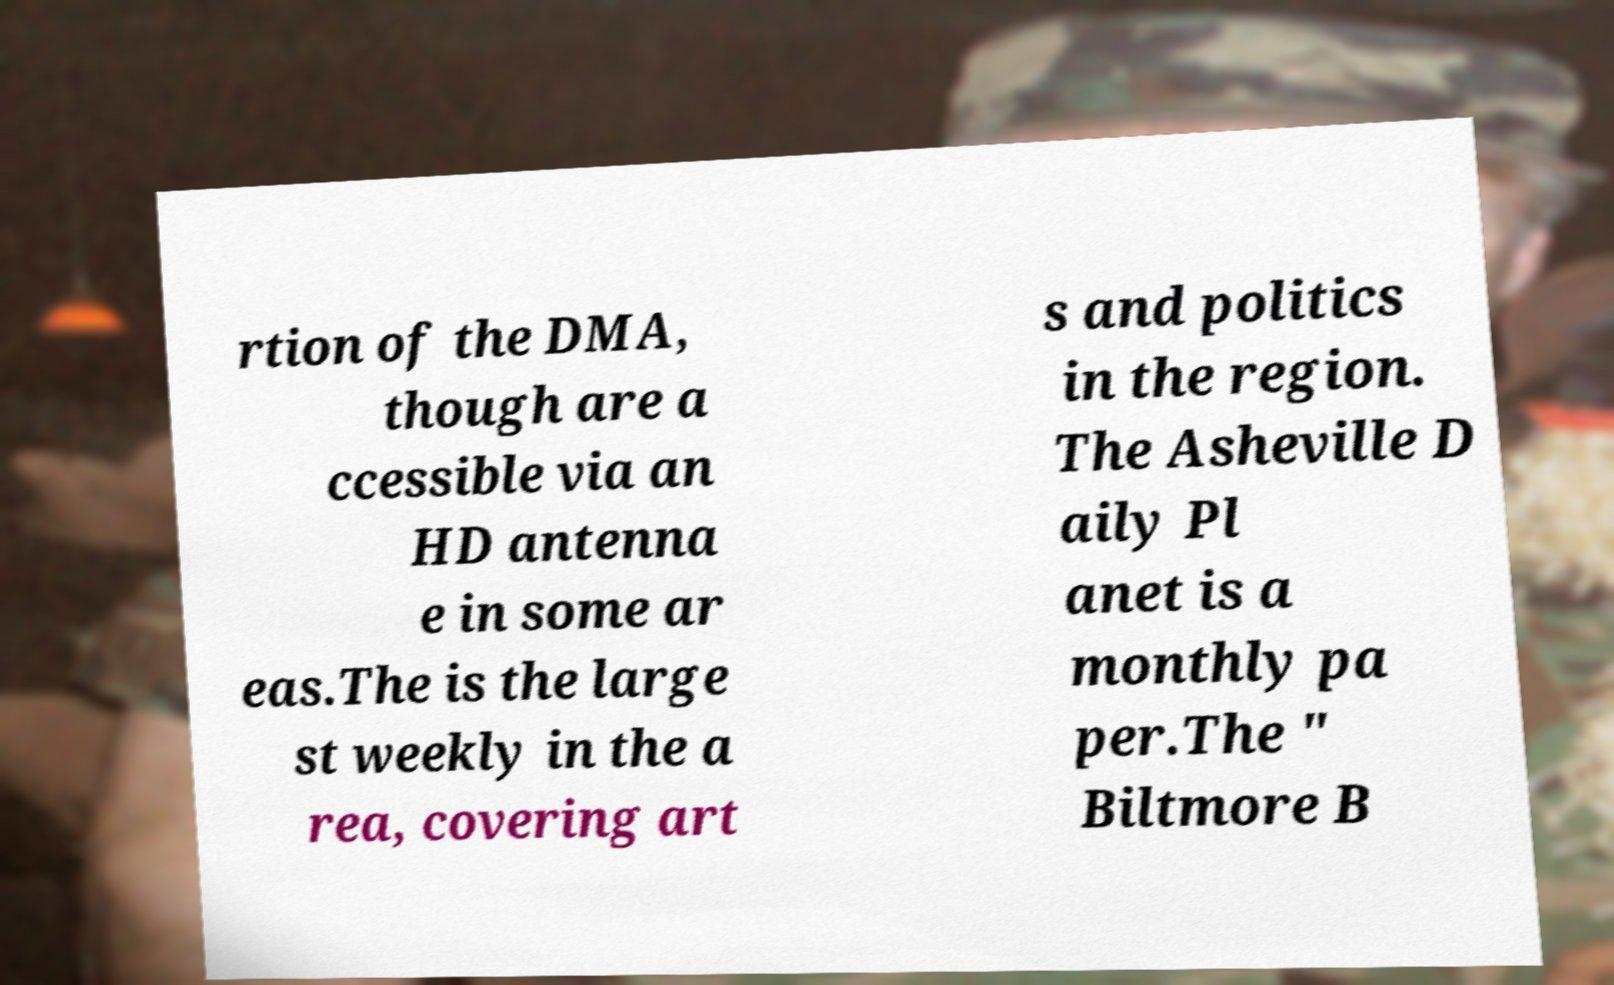There's text embedded in this image that I need extracted. Can you transcribe it verbatim? rtion of the DMA, though are a ccessible via an HD antenna e in some ar eas.The is the large st weekly in the a rea, covering art s and politics in the region. The Asheville D aily Pl anet is a monthly pa per.The " Biltmore B 